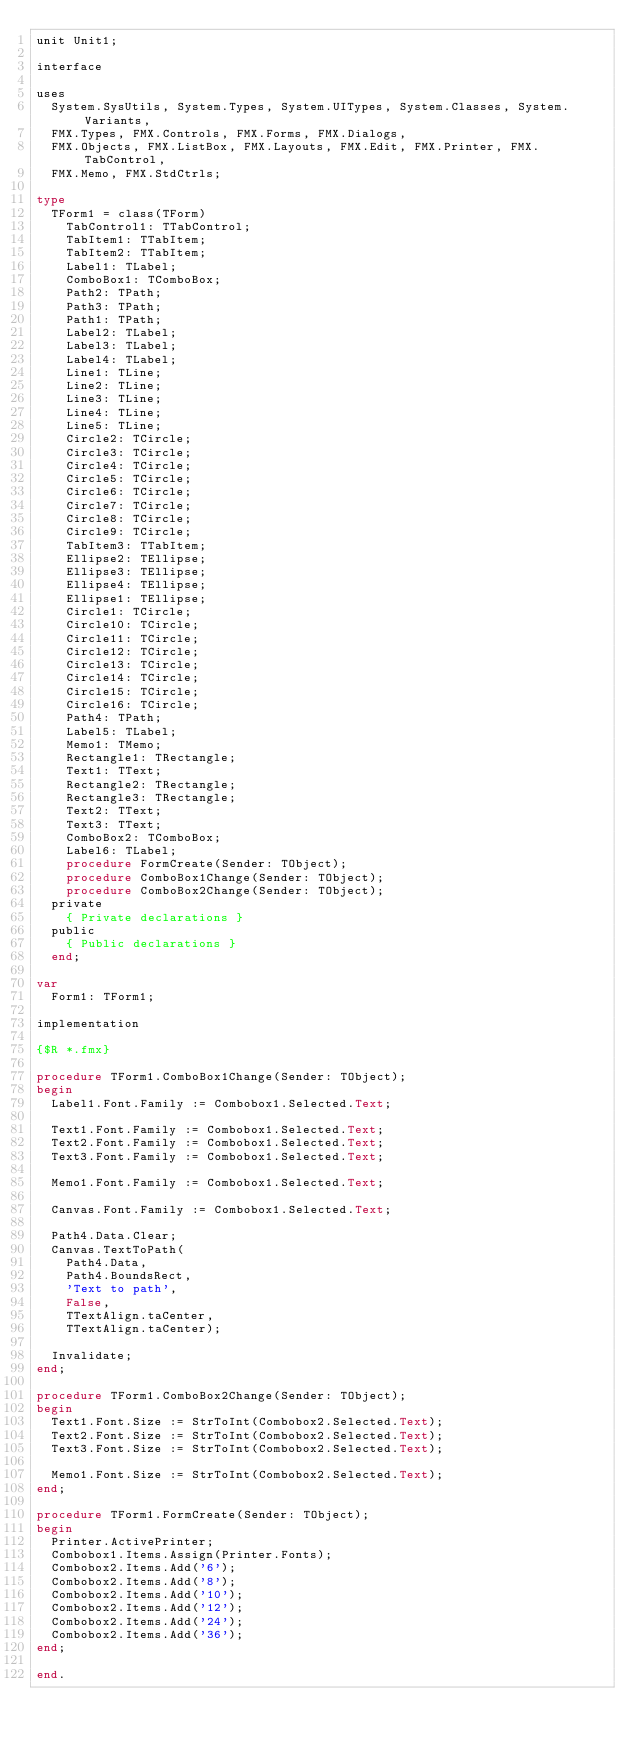<code> <loc_0><loc_0><loc_500><loc_500><_Pascal_>unit Unit1;

interface

uses
  System.SysUtils, System.Types, System.UITypes, System.Classes, System.Variants,
  FMX.Types, FMX.Controls, FMX.Forms, FMX.Dialogs,
  FMX.Objects, FMX.ListBox, FMX.Layouts, FMX.Edit, FMX.Printer, FMX.TabControl,
  FMX.Memo, FMX.StdCtrls;

type
  TForm1 = class(TForm)
    TabControl1: TTabControl;
    TabItem1: TTabItem;
    TabItem2: TTabItem;
    Label1: TLabel;
    ComboBox1: TComboBox;
    Path2: TPath;
    Path3: TPath;
    Path1: TPath;
    Label2: TLabel;
    Label3: TLabel;
    Label4: TLabel;
    Line1: TLine;
    Line2: TLine;
    Line3: TLine;
    Line4: TLine;
    Line5: TLine;
    Circle2: TCircle;
    Circle3: TCircle;
    Circle4: TCircle;
    Circle5: TCircle;
    Circle6: TCircle;
    Circle7: TCircle;
    Circle8: TCircle;
    Circle9: TCircle;
    TabItem3: TTabItem;
    Ellipse2: TEllipse;
    Ellipse3: TEllipse;
    Ellipse4: TEllipse;
    Ellipse1: TEllipse;
    Circle1: TCircle;
    Circle10: TCircle;
    Circle11: TCircle;
    Circle12: TCircle;
    Circle13: TCircle;
    Circle14: TCircle;
    Circle15: TCircle;
    Circle16: TCircle;
    Path4: TPath;
    Label5: TLabel;
    Memo1: TMemo;
    Rectangle1: TRectangle;
    Text1: TText;
    Rectangle2: TRectangle;
    Rectangle3: TRectangle;
    Text2: TText;
    Text3: TText;
    ComboBox2: TComboBox;
    Label6: TLabel;
    procedure FormCreate(Sender: TObject);
    procedure ComboBox1Change(Sender: TObject);
    procedure ComboBox2Change(Sender: TObject);
  private
    { Private declarations }
  public
    { Public declarations }
  end;

var
  Form1: TForm1;

implementation

{$R *.fmx}

procedure TForm1.ComboBox1Change(Sender: TObject);
begin
  Label1.Font.Family := Combobox1.Selected.Text;

  Text1.Font.Family := Combobox1.Selected.Text;
  Text2.Font.Family := Combobox1.Selected.Text;
  Text3.Font.Family := Combobox1.Selected.Text;

  Memo1.Font.Family := Combobox1.Selected.Text;

  Canvas.Font.Family := Combobox1.Selected.Text;

  Path4.Data.Clear;
  Canvas.TextToPath(
    Path4.Data,
    Path4.BoundsRect,
    'Text to path',
    False,
    TTextAlign.taCenter,
    TTextAlign.taCenter);

  Invalidate;
end;

procedure TForm1.ComboBox2Change(Sender: TObject);
begin
  Text1.Font.Size := StrToInt(Combobox2.Selected.Text);
  Text2.Font.Size := StrToInt(Combobox2.Selected.Text);
  Text3.Font.Size := StrToInt(Combobox2.Selected.Text);

  Memo1.Font.Size := StrToInt(Combobox2.Selected.Text);
end;

procedure TForm1.FormCreate(Sender: TObject);
begin
  Printer.ActivePrinter;
  Combobox1.Items.Assign(Printer.Fonts);
  Combobox2.Items.Add('6');
  Combobox2.Items.Add('8');
  Combobox2.Items.Add('10');
  Combobox2.Items.Add('12');
  Combobox2.Items.Add('24');
  Combobox2.Items.Add('36');
end;

end.
</code> 